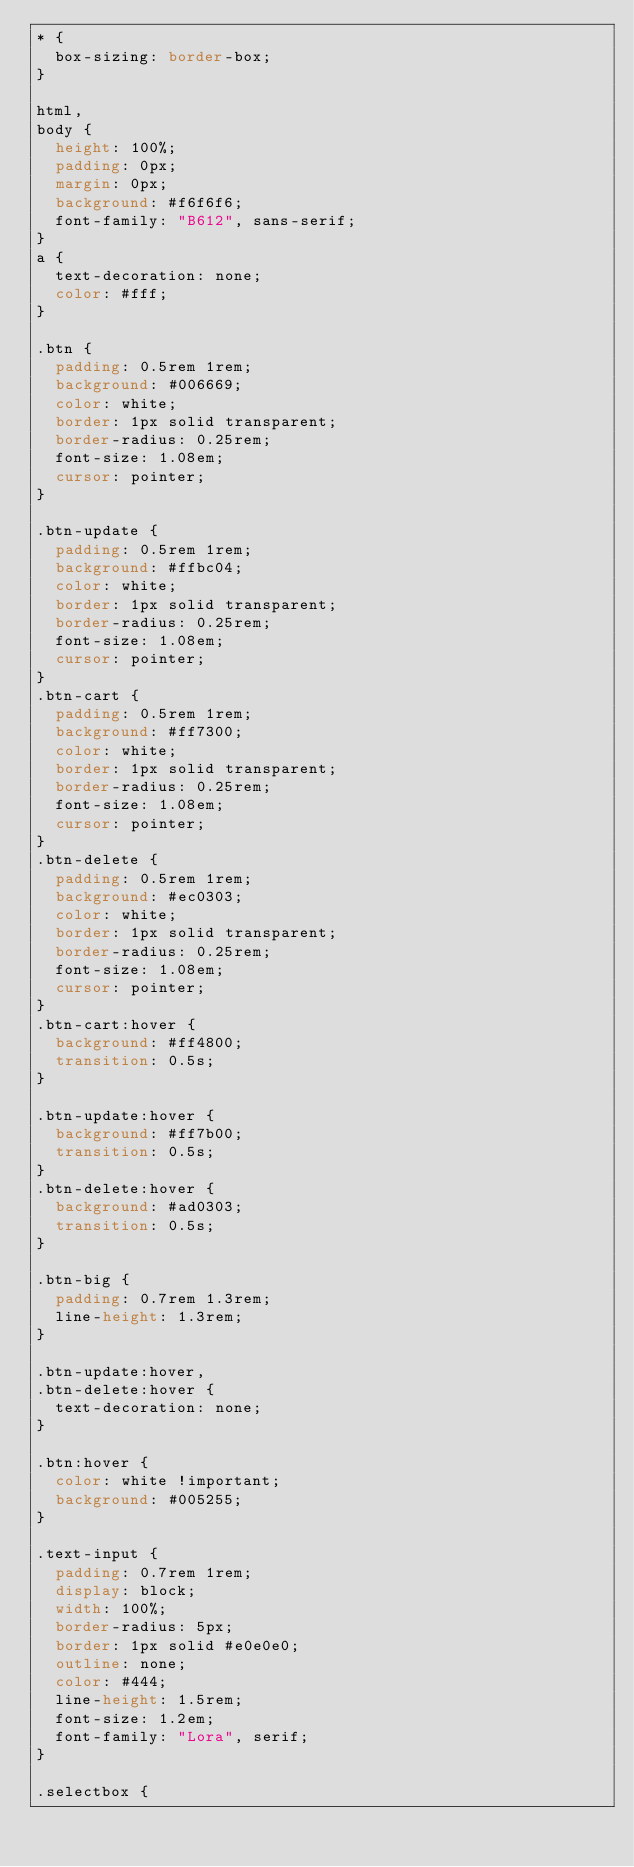Convert code to text. <code><loc_0><loc_0><loc_500><loc_500><_CSS_>* {
  box-sizing: border-box;
}

html,
body {
  height: 100%;
  padding: 0px;
  margin: 0px;
  background: #f6f6f6;
  font-family: "B612", sans-serif;
}
a {
  text-decoration: none;
  color: #fff;
}

.btn {
  padding: 0.5rem 1rem;
  background: #006669;
  color: white;
  border: 1px solid transparent;
  border-radius: 0.25rem;
  font-size: 1.08em;
  cursor: pointer;
}

.btn-update {
  padding: 0.5rem 1rem;
  background: #ffbc04;
  color: white;
  border: 1px solid transparent;
  border-radius: 0.25rem;
  font-size: 1.08em;
  cursor: pointer;
}
.btn-cart {
  padding: 0.5rem 1rem;
  background: #ff7300;
  color: white;
  border: 1px solid transparent;
  border-radius: 0.25rem;
  font-size: 1.08em;
  cursor: pointer;
}
.btn-delete {
  padding: 0.5rem 1rem;
  background: #ec0303;
  color: white;
  border: 1px solid transparent;
  border-radius: 0.25rem;
  font-size: 1.08em;
  cursor: pointer;
}
.btn-cart:hover {
  background: #ff4800;
  transition: 0.5s;
}

.btn-update:hover {
  background: #ff7b00;
  transition: 0.5s;
}
.btn-delete:hover {
  background: #ad0303;
  transition: 0.5s;
}

.btn-big {
  padding: 0.7rem 1.3rem;
  line-height: 1.3rem;
}

.btn-update:hover,
.btn-delete:hover {
  text-decoration: none;
}

.btn:hover {
  color: white !important;
  background: #005255;
}

.text-input {
  padding: 0.7rem 1rem;
  display: block;
  width: 100%;
  border-radius: 5px;
  border: 1px solid #e0e0e0;
  outline: none;
  color: #444;
  line-height: 1.5rem;
  font-size: 1.2em;
  font-family: "Lora", serif;
}

.selectbox {</code> 